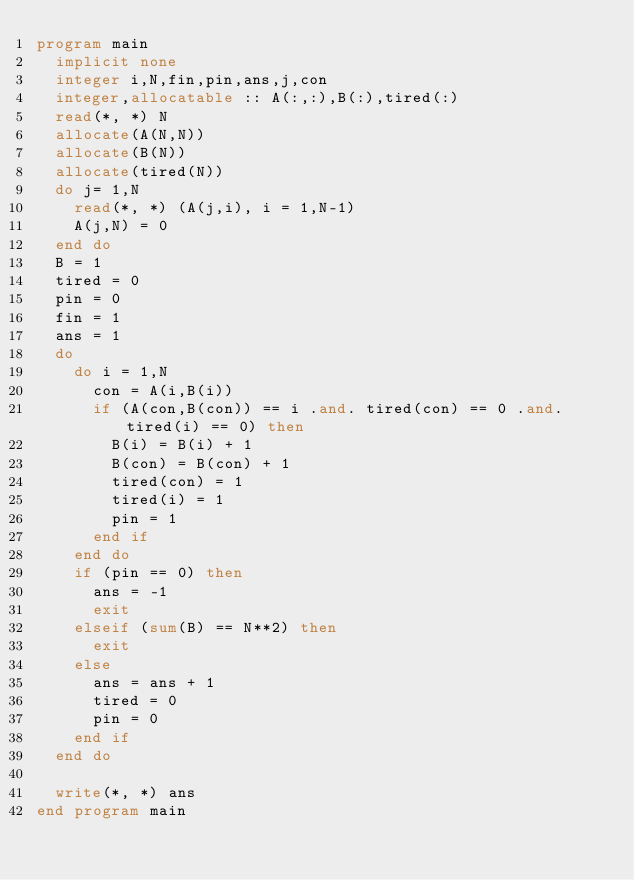Convert code to text. <code><loc_0><loc_0><loc_500><loc_500><_FORTRAN_>program main
  implicit none
  integer i,N,fin,pin,ans,j,con
  integer,allocatable :: A(:,:),B(:),tired(:)
  read(*, *) N
  allocate(A(N,N))
  allocate(B(N))
  allocate(tired(N))
  do j= 1,N
    read(*, *) (A(j,i), i = 1,N-1)
    A(j,N) = 0
  end do
  B = 1
  tired = 0
  pin = 0
  fin = 1
  ans = 1
  do
    do i = 1,N
      con = A(i,B(i))
      if (A(con,B(con)) == i .and. tired(con) == 0 .and. tired(i) == 0) then
        B(i) = B(i) + 1
        B(con) = B(con) + 1
        tired(con) = 1
        tired(i) = 1
        pin = 1
      end if
    end do
    if (pin == 0) then
      ans = -1
      exit
    elseif (sum(B) == N**2) then
      exit
    else
      ans = ans + 1
      tired = 0
      pin = 0
    end if
  end do
    
  write(*, *) ans
end program main
</code> 